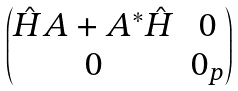Convert formula to latex. <formula><loc_0><loc_0><loc_500><loc_500>\begin{pmatrix} \hat { H } A + A ^ { * } \hat { H } & 0 \\ 0 & 0 _ { p } \end{pmatrix}</formula> 